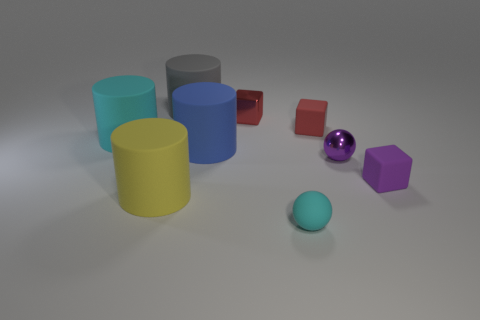What number of tiny blocks are right of the cyan thing that is in front of the big yellow cylinder?
Provide a short and direct response. 2. Are there any tiny yellow things that have the same shape as the tiny cyan object?
Give a very brief answer. No. There is a cyan thing left of the large blue cylinder; is its size the same as the cyan thing in front of the yellow cylinder?
Provide a succinct answer. No. There is a large rubber object behind the cyan thing that is left of the gray rubber object; what is its shape?
Your answer should be compact. Cylinder. How many gray matte objects have the same size as the purple metal thing?
Your answer should be very brief. 0. Are any big gray things visible?
Your answer should be compact. Yes. Is there anything else of the same color as the matte sphere?
Your answer should be very brief. Yes. What shape is the small thing that is made of the same material as the purple ball?
Provide a short and direct response. Cube. There is a metal thing that is to the right of the small shiny thing behind the large matte thing to the right of the gray cylinder; what color is it?
Offer a very short reply. Purple. Are there an equal number of cylinders that are behind the tiny purple shiny thing and large brown metal things?
Ensure brevity in your answer.  No. 